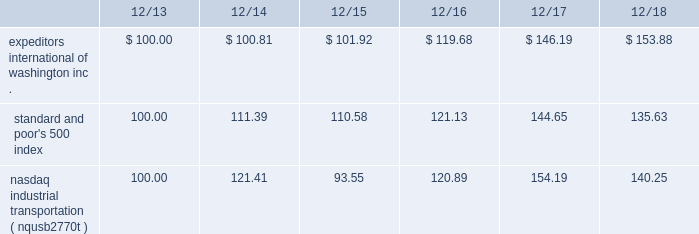The graph below compares expeditors international of washington , inc.'s cumulative 5-year total shareholder return on common stock with the cumulative total returns of the s&p 500 index and the nasdaq industrial transportation index ( nqusb2770t ) .
The graph assumes that the value of the investment in our common stock and in each of the indexes ( including reinvestment of dividends ) was $ 100 on 12/31/2013 and tracks it through 12/31/2018 .
Total return assumes reinvestment of dividends in each of the indices indicated .
Comparison of 5-year cumulative total return among expeditors international of washington , inc. , the s&p 500 index and the nasdaq industrial transportation index. .
The stock price performance included in this graph is not necessarily indicative of future stock price performance. .
What is the highest return rate for the first year of the investment? 
Rationale: it is the maximum value turned into a percentage .
Computations: (121.41 - 100)
Answer: 21.41. 